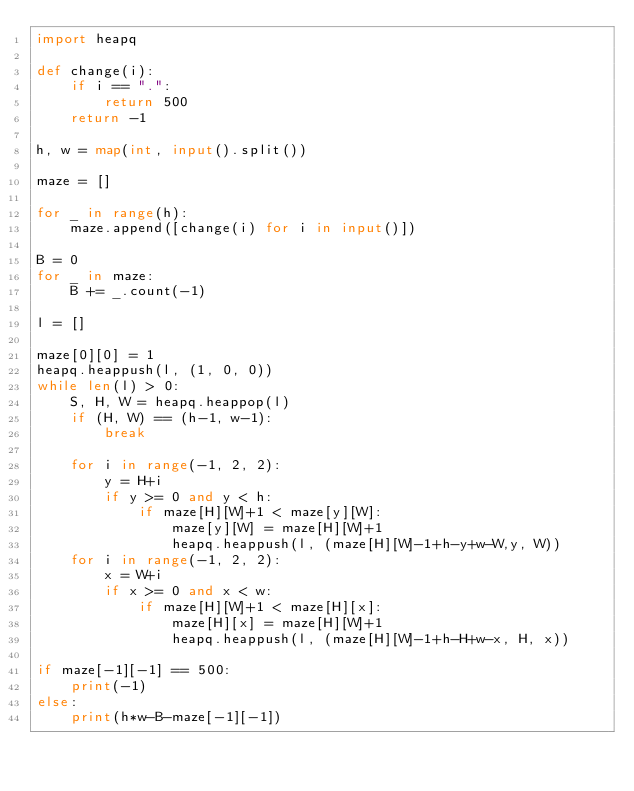Convert code to text. <code><loc_0><loc_0><loc_500><loc_500><_Python_>import heapq

def change(i):
    if i == ".":
        return 500
    return -1

h, w = map(int, input().split())

maze = []

for _ in range(h):
    maze.append([change(i) for i in input()])

B = 0
for _ in maze:
    B += _.count(-1)

l = []

maze[0][0] = 1
heapq.heappush(l, (1, 0, 0))
while len(l) > 0:
    S, H, W = heapq.heappop(l)
    if (H, W) == (h-1, w-1):
        break
    
    for i in range(-1, 2, 2):
        y = H+i
        if y >= 0 and y < h:
            if maze[H][W]+1 < maze[y][W]:
                maze[y][W] = maze[H][W]+1
                heapq.heappush(l, (maze[H][W]-1+h-y+w-W,y, W))
    for i in range(-1, 2, 2):
        x = W+i
        if x >= 0 and x < w:
            if maze[H][W]+1 < maze[H][x]:
                maze[H][x] = maze[H][W]+1
                heapq.heappush(l, (maze[H][W]-1+h-H+w-x, H, x))

if maze[-1][-1] == 500:
    print(-1)
else:
    print(h*w-B-maze[-1][-1]) </code> 